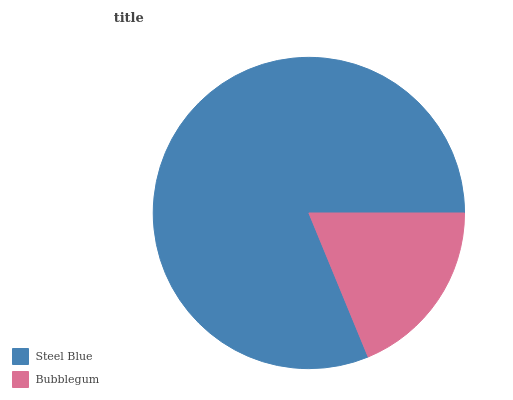Is Bubblegum the minimum?
Answer yes or no. Yes. Is Steel Blue the maximum?
Answer yes or no. Yes. Is Bubblegum the maximum?
Answer yes or no. No. Is Steel Blue greater than Bubblegum?
Answer yes or no. Yes. Is Bubblegum less than Steel Blue?
Answer yes or no. Yes. Is Bubblegum greater than Steel Blue?
Answer yes or no. No. Is Steel Blue less than Bubblegum?
Answer yes or no. No. Is Steel Blue the high median?
Answer yes or no. Yes. Is Bubblegum the low median?
Answer yes or no. Yes. Is Bubblegum the high median?
Answer yes or no. No. Is Steel Blue the low median?
Answer yes or no. No. 